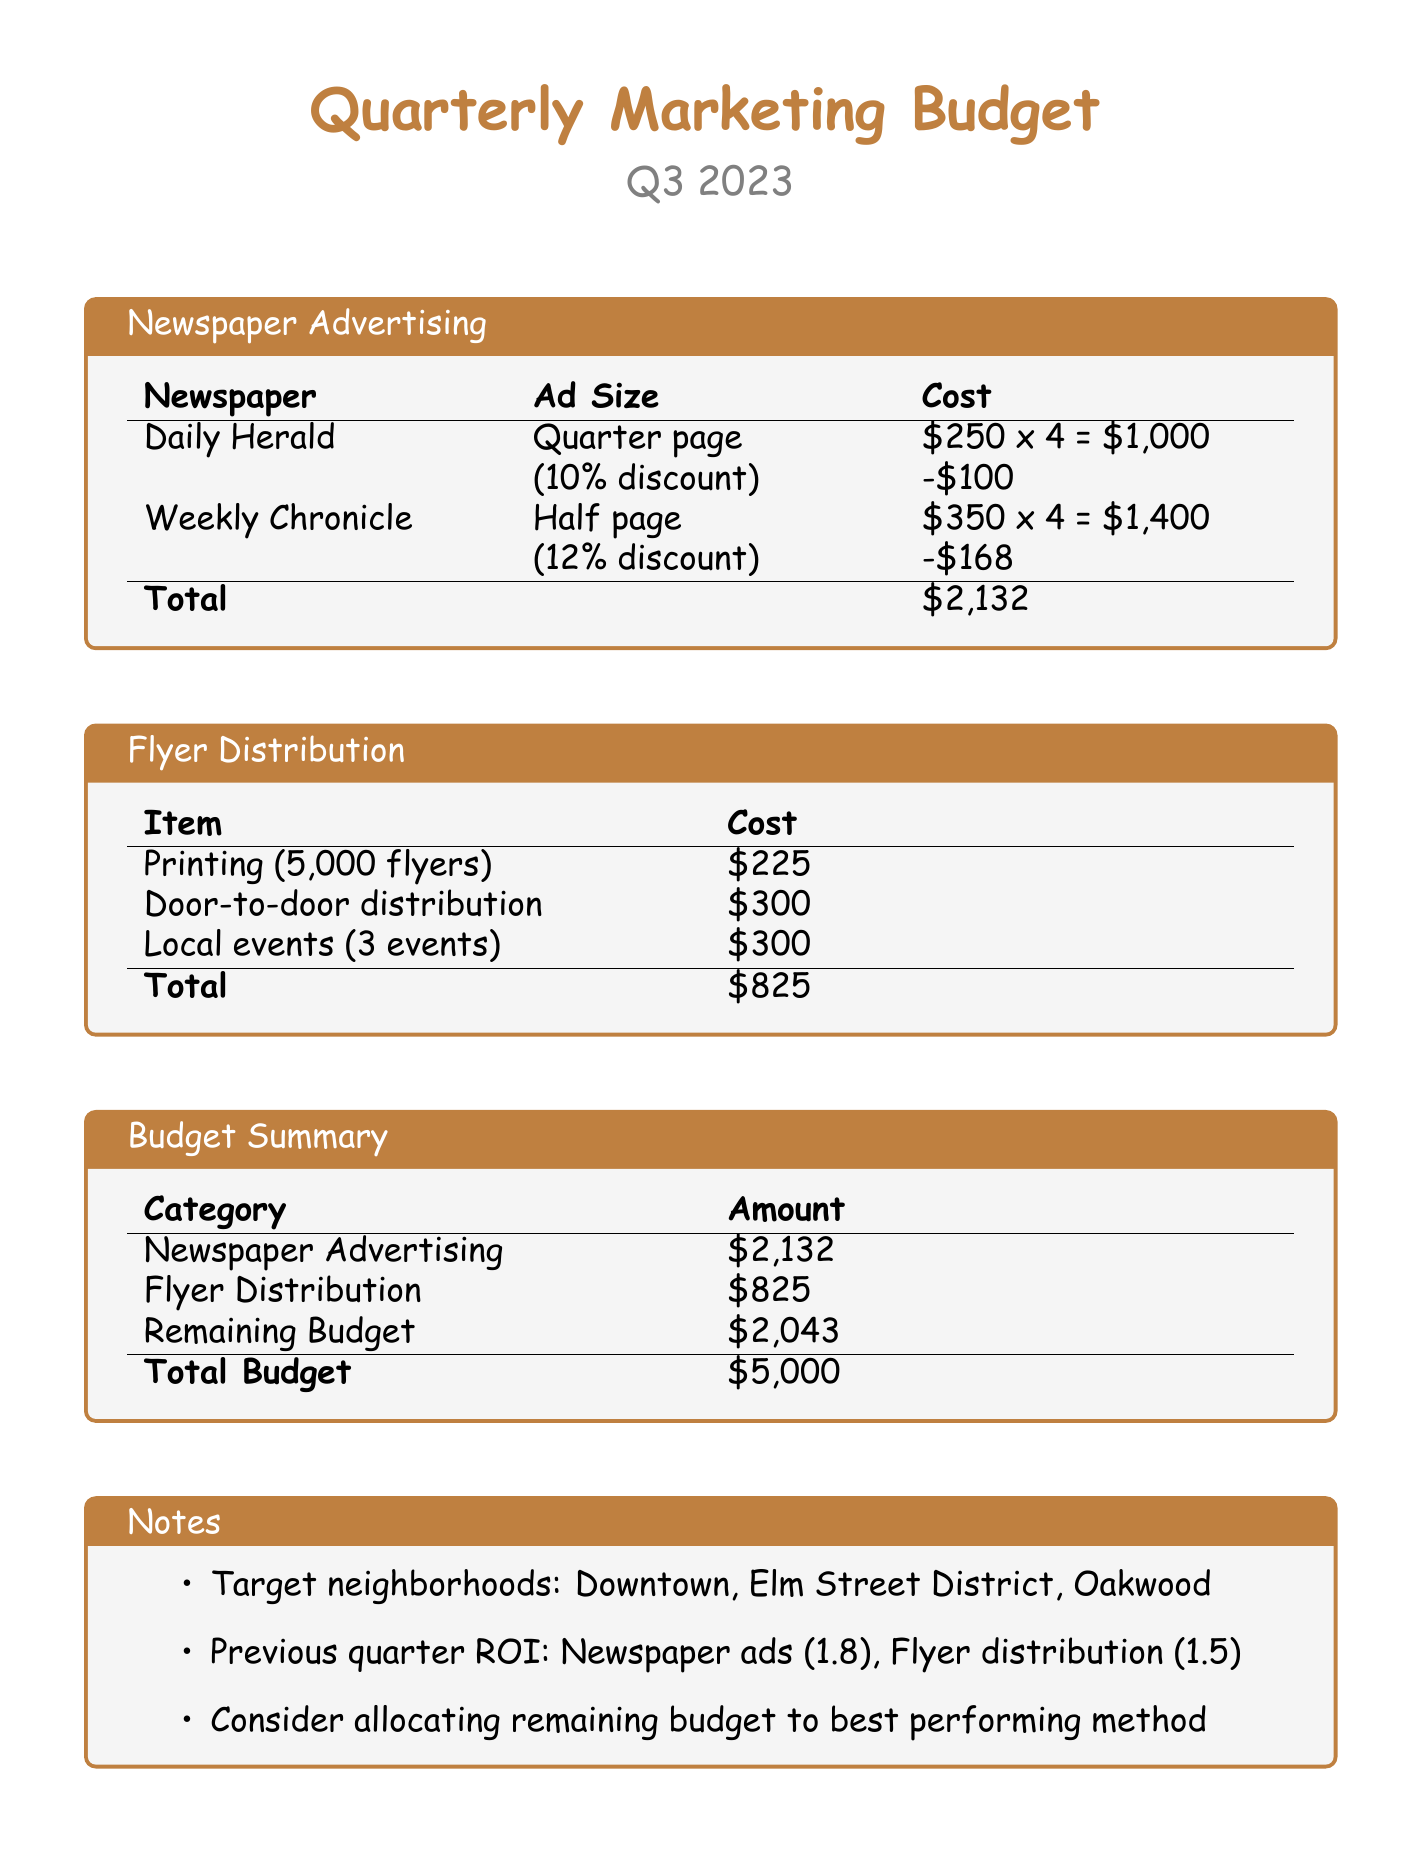What is the total cost of newspaper advertising? The total cost of newspaper advertising is listed under the Budget Summary section, which is $2,132.
Answer: $2,132 How much is spent on flyer distribution? The amount spent on flyer distribution is specified in the Flyer Distribution section, which totals $825.
Answer: $825 What is the cost of printing 5,000 flyers? The cost for printing 5,000 flyers is mentioned in the Flyer Distribution section and is $225.
Answer: $225 What is the remaining budget after expenses? The remaining budget is calculated in the Budget Summary section, which shows $2,043.
Answer: $2,043 Which neighborhoods are targeted in this marketing budget? The target neighborhoods are detailed in the Notes section, which lists Downtown, Elm Street District, and Oakwood.
Answer: Downtown, Elm Street District, Oakwood What is the discount percentage for the Daily Herald? The discount percentage for the Daily Herald is provided in the Newspaper Advertising section, which is 10%.
Answer: 10% What is the total budget allocated for marketing? The total budget is stated in the Budget Summary section, which is $5,000.
Answer: $5,000 How many events are included in the flyer distribution? The number of events for flyer distribution is specified in the Flyer Distribution section, which mentions 3 events.
Answer: 3 events What was the ROI for newspaper ads in the previous quarter? The ROI for newspaper ads is detailed in the Notes section, stating it was 1.8.
Answer: 1.8 What type of ad is featured in the Weekly Chronicle? The type of ad in the Weekly Chronicle is mentioned in the Newspaper Advertising section as a half page.
Answer: Half page 